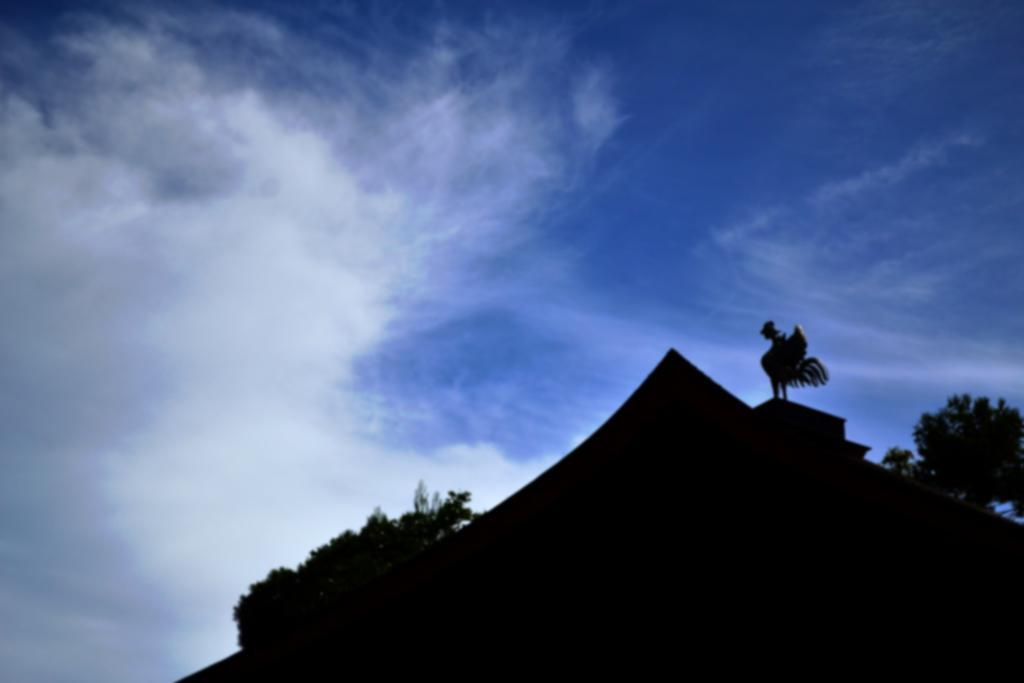What type of natural elements can be seen in the image? There are trees and clouds in the image. What part of the natural environment is visible in the image? The sky is visible in the image. What is the color of the black object in the image? The black object in the image is black. How would you describe the overall lighting in the image? The image appears to be slightly dark. Can you see any sparks flying between the trees in the image? No, there are no sparks visible in the image. The image does not depict any sparks or spark-related events. 